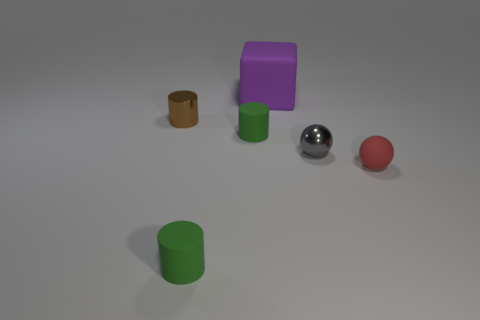Add 3 small cylinders. How many objects exist? 9 Subtract all cubes. How many objects are left? 5 Subtract 0 gray cylinders. How many objects are left? 6 Subtract all small red things. Subtract all tiny brown metallic things. How many objects are left? 4 Add 2 small green matte cylinders. How many small green matte cylinders are left? 4 Add 5 small gray metallic spheres. How many small gray metallic spheres exist? 6 